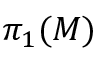Convert formula to latex. <formula><loc_0><loc_0><loc_500><loc_500>\pi _ { 1 } ( M )</formula> 